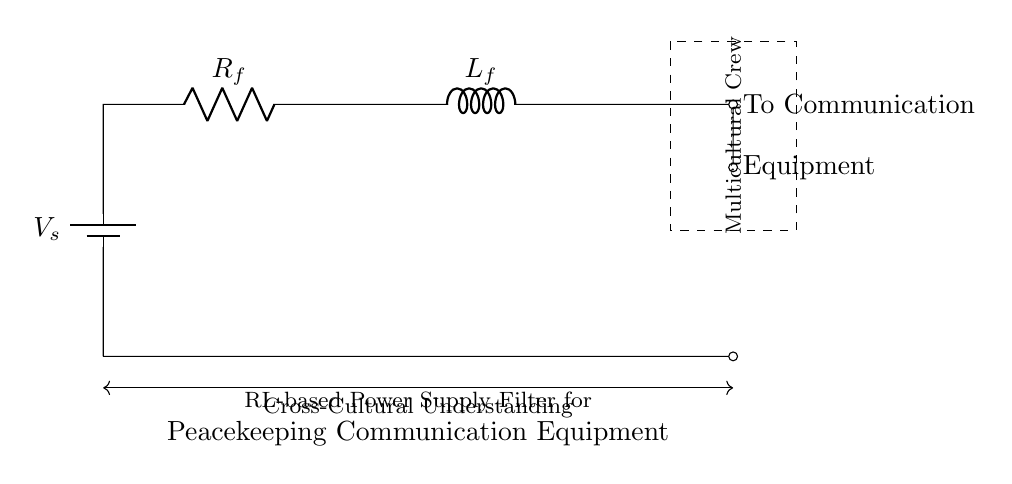What is the supply voltage in this circuit? The supply voltage is labeled as V_s, which is the voltage source providing power to the circuit.
Answer: V_s What components are present in the circuit? The circuit contains a battery (voltage source), a resistor (R_f), and an inductor (L_f), which are the main components shown in the diagram.
Answer: Battery, Resistor, Inductor What is the purpose of the resistor in this circuit? The resistor (R_f) in this circuit is used to limit the current flowing through the circuit and assist in filtering noise, which is essential for effective communication equipment operation.
Answer: Current limiting What is the function of the inductor in this circuit? The inductor (L_f) acts to store energy in a magnetic field, provides impedance to alternating currents, and helps in filtering out high-frequency noise from the power supply.
Answer: Energy storage How does the resistor and inductor combination affect the power supply? The resistor and inductor in series create an RL circuit that filters the power supply, smoothing out voltage variations and minimizing ripple, which is especially important for stable communication in multicultural crew setups.
Answer: Power supply filtering What kind of communication equipment is indicated in the circuit? The circuit specifies that it connects to communication equipment used by a multicultural crew, suggesting that it is tailored for environments requiring effective collaboration and clarity amidst various cultural backgrounds.
Answer: Multicultural crew communication equipment 